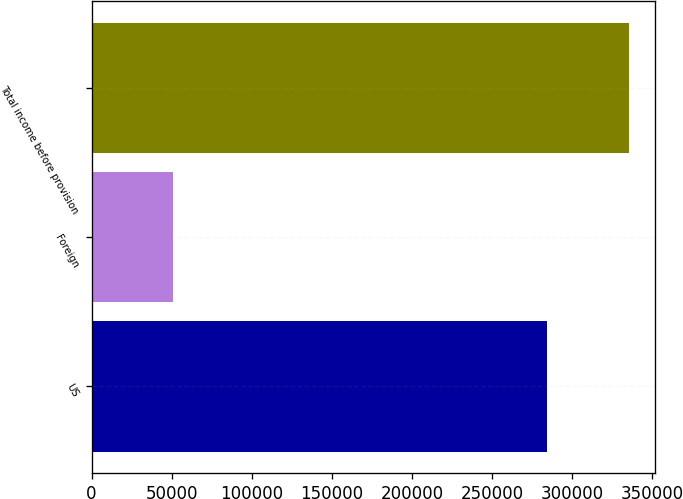<chart> <loc_0><loc_0><loc_500><loc_500><bar_chart><fcel>US<fcel>Foreign<fcel>Total income before provision<nl><fcel>284473<fcel>50730<fcel>335203<nl></chart> 